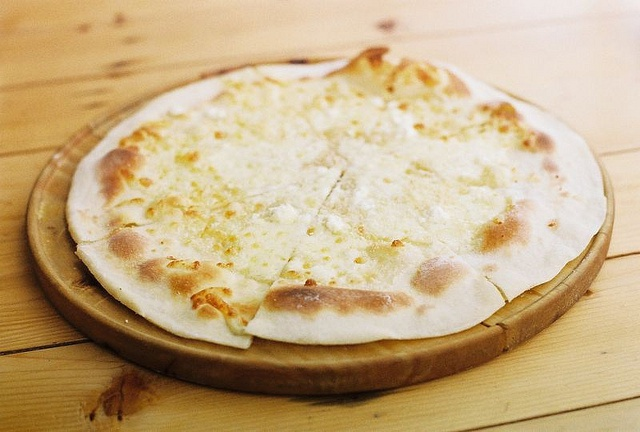Describe the objects in this image and their specific colors. I can see pizza in tan and lightgray tones and dining table in tan, lightgray, and olive tones in this image. 